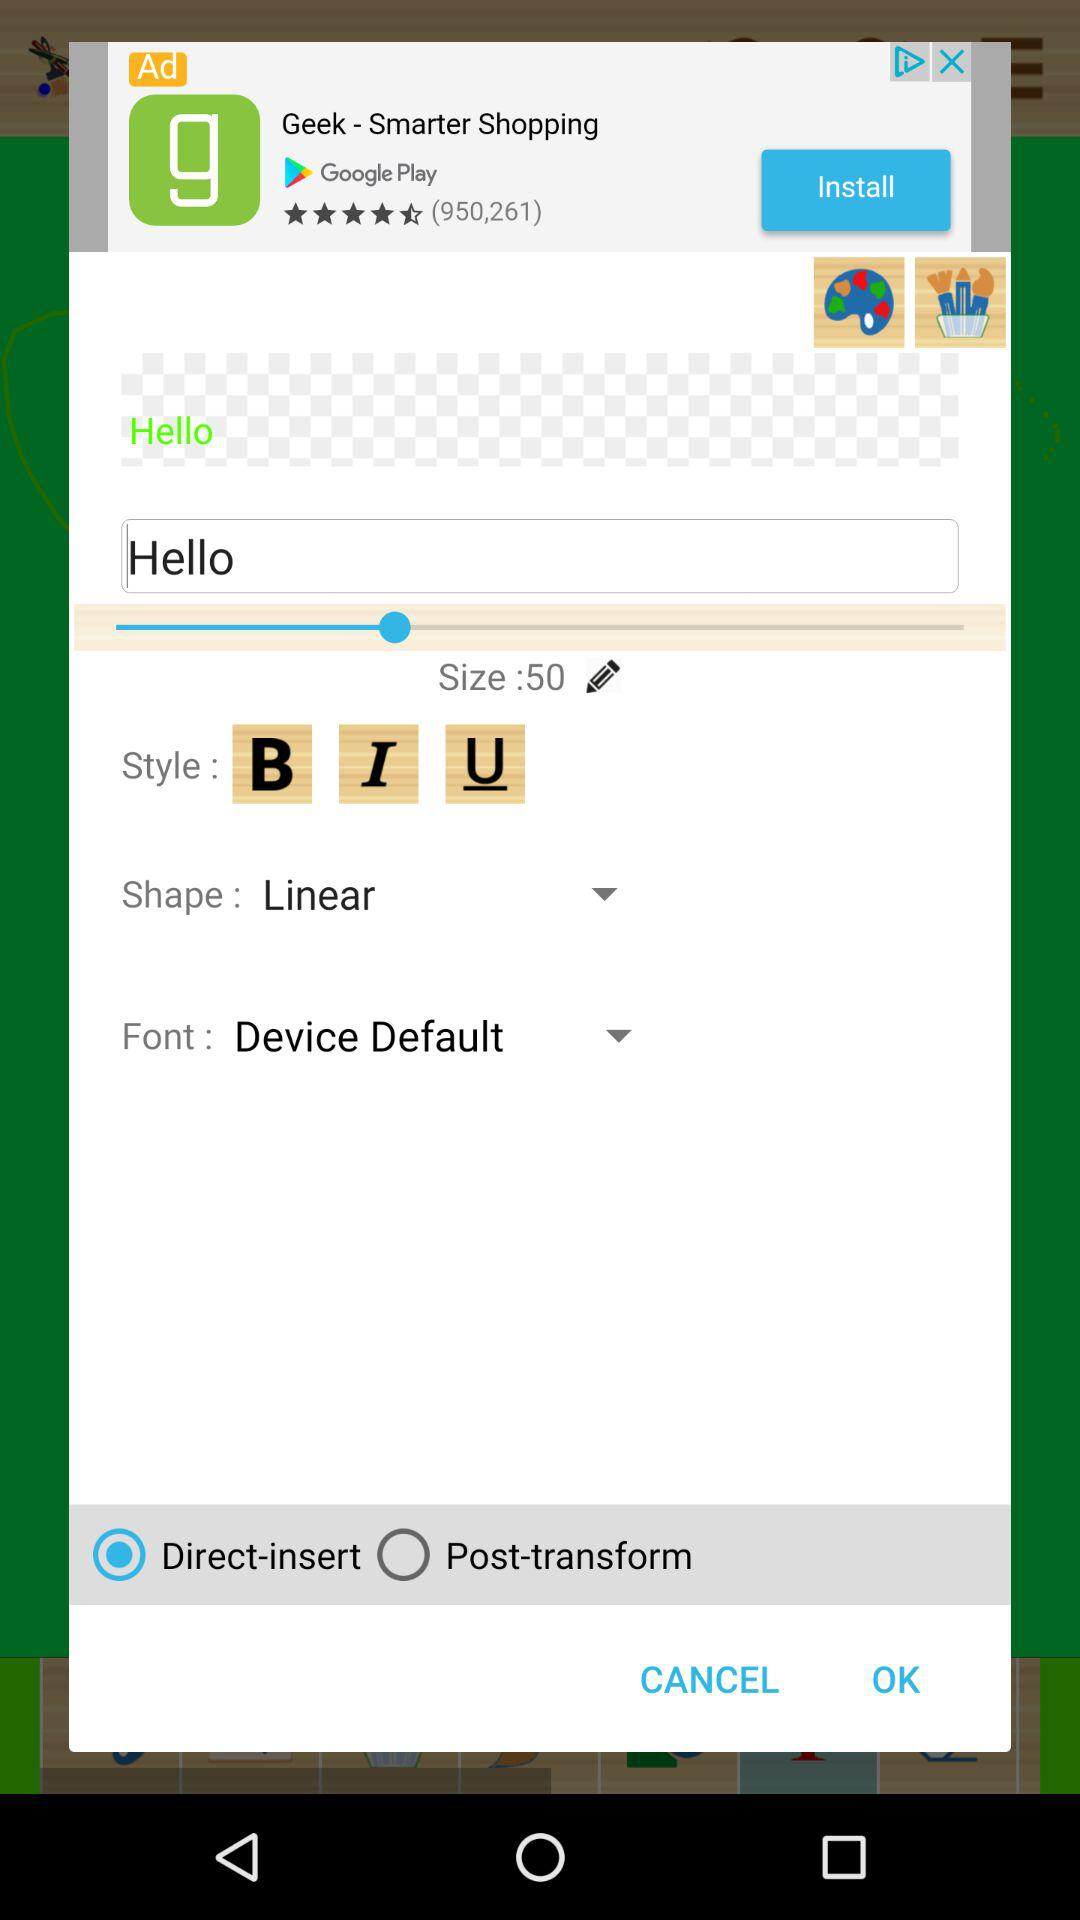What is the shape for text? The shape for text is "Linear". 